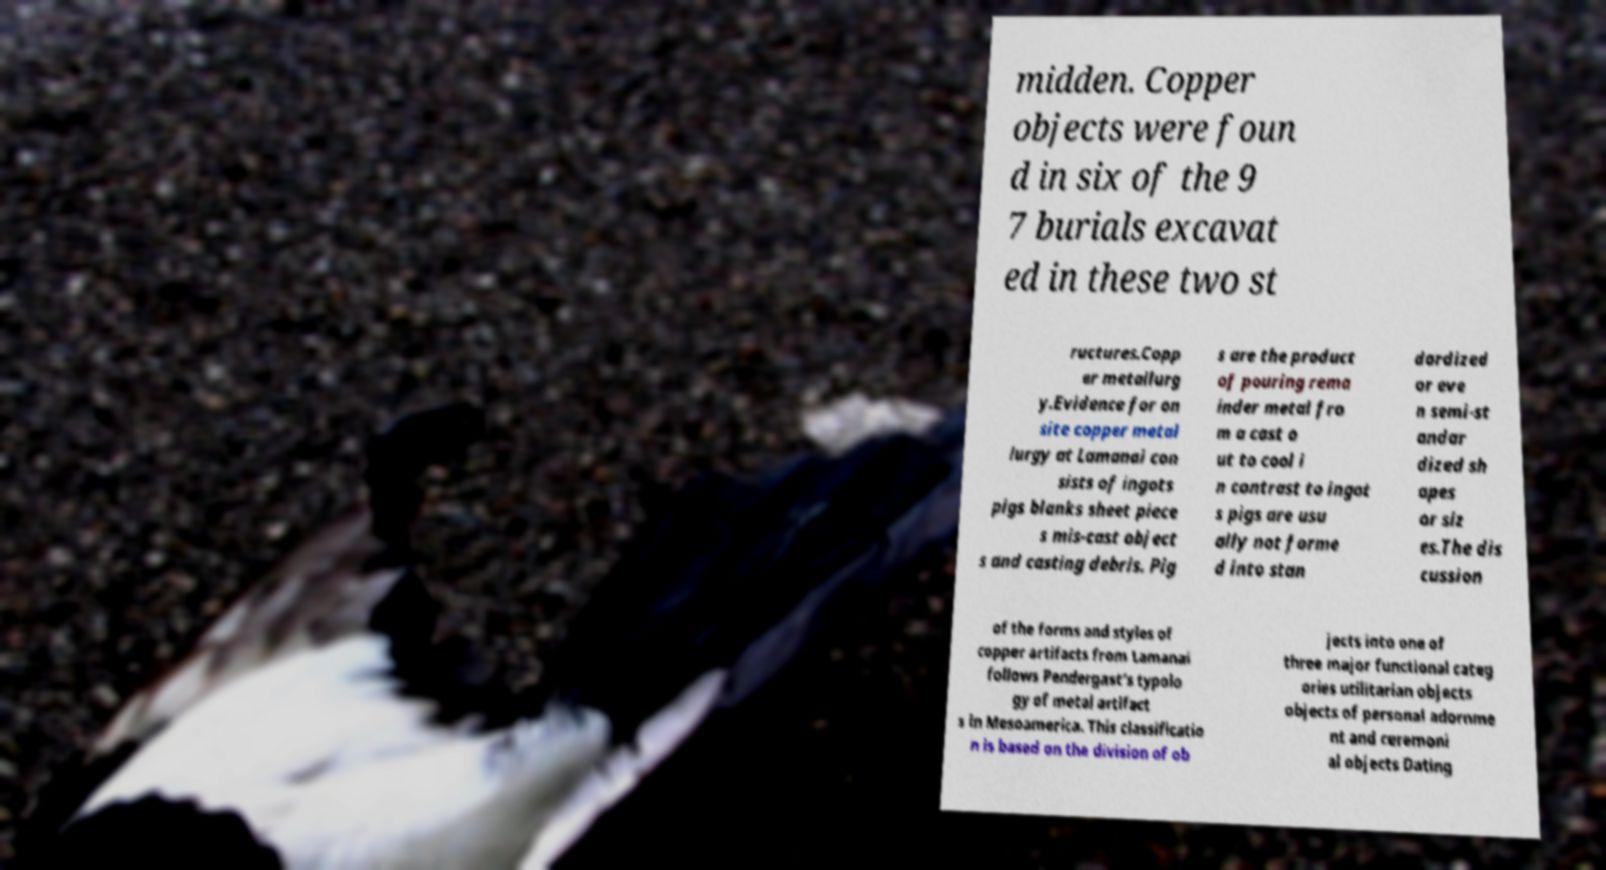Please identify and transcribe the text found in this image. midden. Copper objects were foun d in six of the 9 7 burials excavat ed in these two st ructures.Copp er metallurg y.Evidence for on site copper metal lurgy at Lamanai con sists of ingots pigs blanks sheet piece s mis-cast object s and casting debris. Pig s are the product of pouring rema inder metal fro m a cast o ut to cool i n contrast to ingot s pigs are usu ally not forme d into stan dardized or eve n semi-st andar dized sh apes or siz es.The dis cussion of the forms and styles of copper artifacts from Lamanai follows Pendergast's typolo gy of metal artifact s in Mesoamerica. This classificatio n is based on the division of ob jects into one of three major functional categ ories utilitarian objects objects of personal adornme nt and ceremoni al objects Dating 